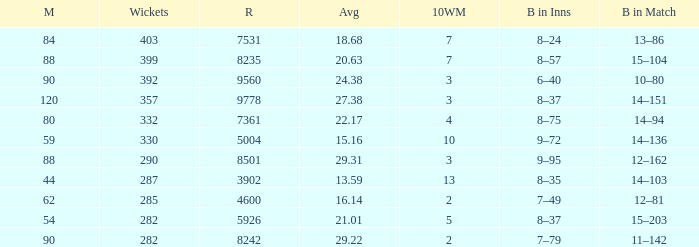How many wickets have runs under 7531, matches over 44, and an average of 22.17? 332.0. 